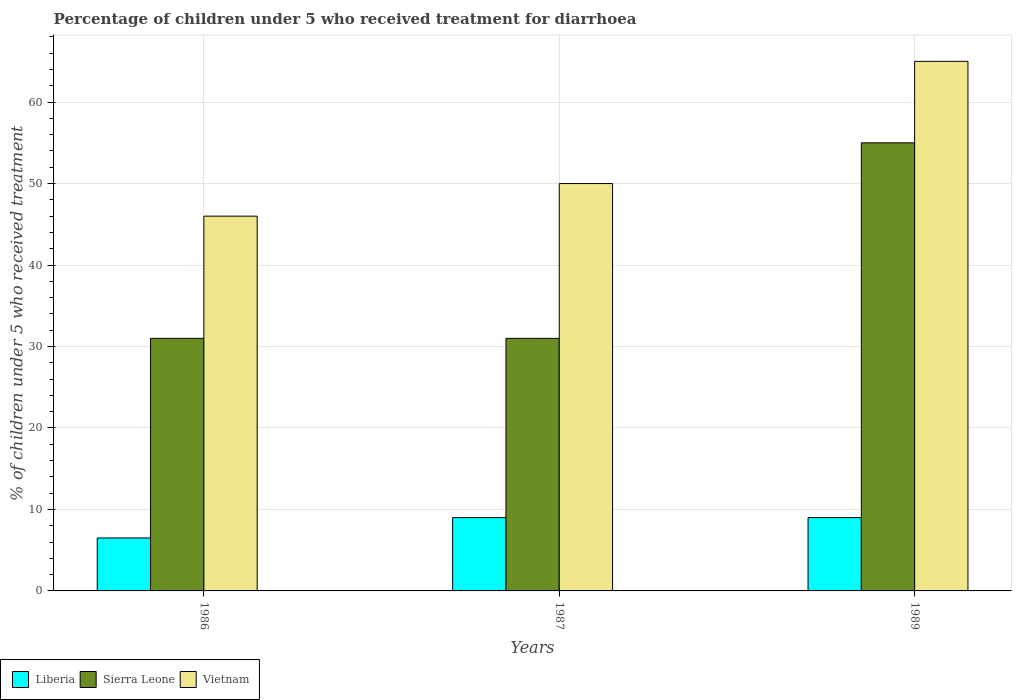How many different coloured bars are there?
Keep it short and to the point. 3. How many groups of bars are there?
Provide a short and direct response. 3. How many bars are there on the 3rd tick from the right?
Your response must be concise. 3. In how many cases, is the number of bars for a given year not equal to the number of legend labels?
Provide a short and direct response. 0. What is the percentage of children who received treatment for diarrhoea  in Sierra Leone in 1987?
Provide a succinct answer. 31. In which year was the percentage of children who received treatment for diarrhoea  in Vietnam maximum?
Keep it short and to the point. 1989. What is the total percentage of children who received treatment for diarrhoea  in Sierra Leone in the graph?
Make the answer very short. 117. What is the difference between the percentage of children who received treatment for diarrhoea  in Liberia in 1987 and the percentage of children who received treatment for diarrhoea  in Vietnam in 1989?
Provide a short and direct response. -56. What is the average percentage of children who received treatment for diarrhoea  in Liberia per year?
Provide a short and direct response. 8.17. In how many years, is the percentage of children who received treatment for diarrhoea  in Vietnam greater than 32 %?
Offer a very short reply. 3. What is the ratio of the percentage of children who received treatment for diarrhoea  in Liberia in 1987 to that in 1989?
Make the answer very short. 1. Is the difference between the percentage of children who received treatment for diarrhoea  in Liberia in 1986 and 1989 greater than the difference between the percentage of children who received treatment for diarrhoea  in Sierra Leone in 1986 and 1989?
Offer a very short reply. Yes. What is the difference between the highest and the second highest percentage of children who received treatment for diarrhoea  in Liberia?
Make the answer very short. 0. In how many years, is the percentage of children who received treatment for diarrhoea  in Vietnam greater than the average percentage of children who received treatment for diarrhoea  in Vietnam taken over all years?
Your response must be concise. 1. Is the sum of the percentage of children who received treatment for diarrhoea  in Liberia in 1986 and 1989 greater than the maximum percentage of children who received treatment for diarrhoea  in Sierra Leone across all years?
Give a very brief answer. No. What does the 3rd bar from the left in 1987 represents?
Make the answer very short. Vietnam. What does the 2nd bar from the right in 1986 represents?
Keep it short and to the point. Sierra Leone. Is it the case that in every year, the sum of the percentage of children who received treatment for diarrhoea  in Vietnam and percentage of children who received treatment for diarrhoea  in Sierra Leone is greater than the percentage of children who received treatment for diarrhoea  in Liberia?
Make the answer very short. Yes. How many bars are there?
Give a very brief answer. 9. Are all the bars in the graph horizontal?
Provide a short and direct response. No. How many years are there in the graph?
Offer a very short reply. 3. What is the difference between two consecutive major ticks on the Y-axis?
Make the answer very short. 10. Does the graph contain any zero values?
Ensure brevity in your answer.  No. What is the title of the graph?
Give a very brief answer. Percentage of children under 5 who received treatment for diarrhoea. What is the label or title of the Y-axis?
Offer a terse response. % of children under 5 who received treatment. What is the % of children under 5 who received treatment of Liberia in 1986?
Offer a very short reply. 6.5. What is the % of children under 5 who received treatment of Vietnam in 1986?
Ensure brevity in your answer.  46. What is the % of children under 5 who received treatment in Liberia in 1987?
Provide a succinct answer. 9. What is the % of children under 5 who received treatment of Sierra Leone in 1989?
Keep it short and to the point. 55. What is the % of children under 5 who received treatment of Vietnam in 1989?
Provide a succinct answer. 65. Across all years, what is the maximum % of children under 5 who received treatment in Sierra Leone?
Ensure brevity in your answer.  55. Across all years, what is the maximum % of children under 5 who received treatment of Vietnam?
Ensure brevity in your answer.  65. Across all years, what is the minimum % of children under 5 who received treatment of Vietnam?
Your answer should be compact. 46. What is the total % of children under 5 who received treatment in Sierra Leone in the graph?
Offer a terse response. 117. What is the total % of children under 5 who received treatment of Vietnam in the graph?
Your answer should be very brief. 161. What is the difference between the % of children under 5 who received treatment of Liberia in 1986 and that in 1987?
Your answer should be compact. -2.5. What is the difference between the % of children under 5 who received treatment in Vietnam in 1986 and that in 1987?
Your response must be concise. -4. What is the difference between the % of children under 5 who received treatment in Vietnam in 1986 and that in 1989?
Offer a very short reply. -19. What is the difference between the % of children under 5 who received treatment of Liberia in 1987 and that in 1989?
Keep it short and to the point. 0. What is the difference between the % of children under 5 who received treatment in Vietnam in 1987 and that in 1989?
Provide a short and direct response. -15. What is the difference between the % of children under 5 who received treatment in Liberia in 1986 and the % of children under 5 who received treatment in Sierra Leone in 1987?
Your answer should be very brief. -24.5. What is the difference between the % of children under 5 who received treatment of Liberia in 1986 and the % of children under 5 who received treatment of Vietnam in 1987?
Ensure brevity in your answer.  -43.5. What is the difference between the % of children under 5 who received treatment of Liberia in 1986 and the % of children under 5 who received treatment of Sierra Leone in 1989?
Your response must be concise. -48.5. What is the difference between the % of children under 5 who received treatment of Liberia in 1986 and the % of children under 5 who received treatment of Vietnam in 1989?
Provide a succinct answer. -58.5. What is the difference between the % of children under 5 who received treatment of Sierra Leone in 1986 and the % of children under 5 who received treatment of Vietnam in 1989?
Your answer should be compact. -34. What is the difference between the % of children under 5 who received treatment of Liberia in 1987 and the % of children under 5 who received treatment of Sierra Leone in 1989?
Keep it short and to the point. -46. What is the difference between the % of children under 5 who received treatment in Liberia in 1987 and the % of children under 5 who received treatment in Vietnam in 1989?
Your answer should be compact. -56. What is the difference between the % of children under 5 who received treatment of Sierra Leone in 1987 and the % of children under 5 who received treatment of Vietnam in 1989?
Ensure brevity in your answer.  -34. What is the average % of children under 5 who received treatment of Liberia per year?
Give a very brief answer. 8.17. What is the average % of children under 5 who received treatment of Vietnam per year?
Keep it short and to the point. 53.67. In the year 1986, what is the difference between the % of children under 5 who received treatment in Liberia and % of children under 5 who received treatment in Sierra Leone?
Offer a very short reply. -24.5. In the year 1986, what is the difference between the % of children under 5 who received treatment of Liberia and % of children under 5 who received treatment of Vietnam?
Give a very brief answer. -39.5. In the year 1986, what is the difference between the % of children under 5 who received treatment in Sierra Leone and % of children under 5 who received treatment in Vietnam?
Provide a short and direct response. -15. In the year 1987, what is the difference between the % of children under 5 who received treatment in Liberia and % of children under 5 who received treatment in Sierra Leone?
Provide a succinct answer. -22. In the year 1987, what is the difference between the % of children under 5 who received treatment of Liberia and % of children under 5 who received treatment of Vietnam?
Give a very brief answer. -41. In the year 1987, what is the difference between the % of children under 5 who received treatment of Sierra Leone and % of children under 5 who received treatment of Vietnam?
Give a very brief answer. -19. In the year 1989, what is the difference between the % of children under 5 who received treatment in Liberia and % of children under 5 who received treatment in Sierra Leone?
Your response must be concise. -46. In the year 1989, what is the difference between the % of children under 5 who received treatment of Liberia and % of children under 5 who received treatment of Vietnam?
Offer a terse response. -56. In the year 1989, what is the difference between the % of children under 5 who received treatment of Sierra Leone and % of children under 5 who received treatment of Vietnam?
Your answer should be very brief. -10. What is the ratio of the % of children under 5 who received treatment in Liberia in 1986 to that in 1987?
Offer a very short reply. 0.72. What is the ratio of the % of children under 5 who received treatment in Vietnam in 1986 to that in 1987?
Your answer should be compact. 0.92. What is the ratio of the % of children under 5 who received treatment in Liberia in 1986 to that in 1989?
Give a very brief answer. 0.72. What is the ratio of the % of children under 5 who received treatment of Sierra Leone in 1986 to that in 1989?
Your response must be concise. 0.56. What is the ratio of the % of children under 5 who received treatment in Vietnam in 1986 to that in 1989?
Offer a very short reply. 0.71. What is the ratio of the % of children under 5 who received treatment of Liberia in 1987 to that in 1989?
Offer a very short reply. 1. What is the ratio of the % of children under 5 who received treatment in Sierra Leone in 1987 to that in 1989?
Provide a short and direct response. 0.56. What is the ratio of the % of children under 5 who received treatment in Vietnam in 1987 to that in 1989?
Provide a succinct answer. 0.77. What is the difference between the highest and the second highest % of children under 5 who received treatment of Sierra Leone?
Offer a terse response. 24. What is the difference between the highest and the lowest % of children under 5 who received treatment in Sierra Leone?
Offer a very short reply. 24. What is the difference between the highest and the lowest % of children under 5 who received treatment in Vietnam?
Provide a short and direct response. 19. 